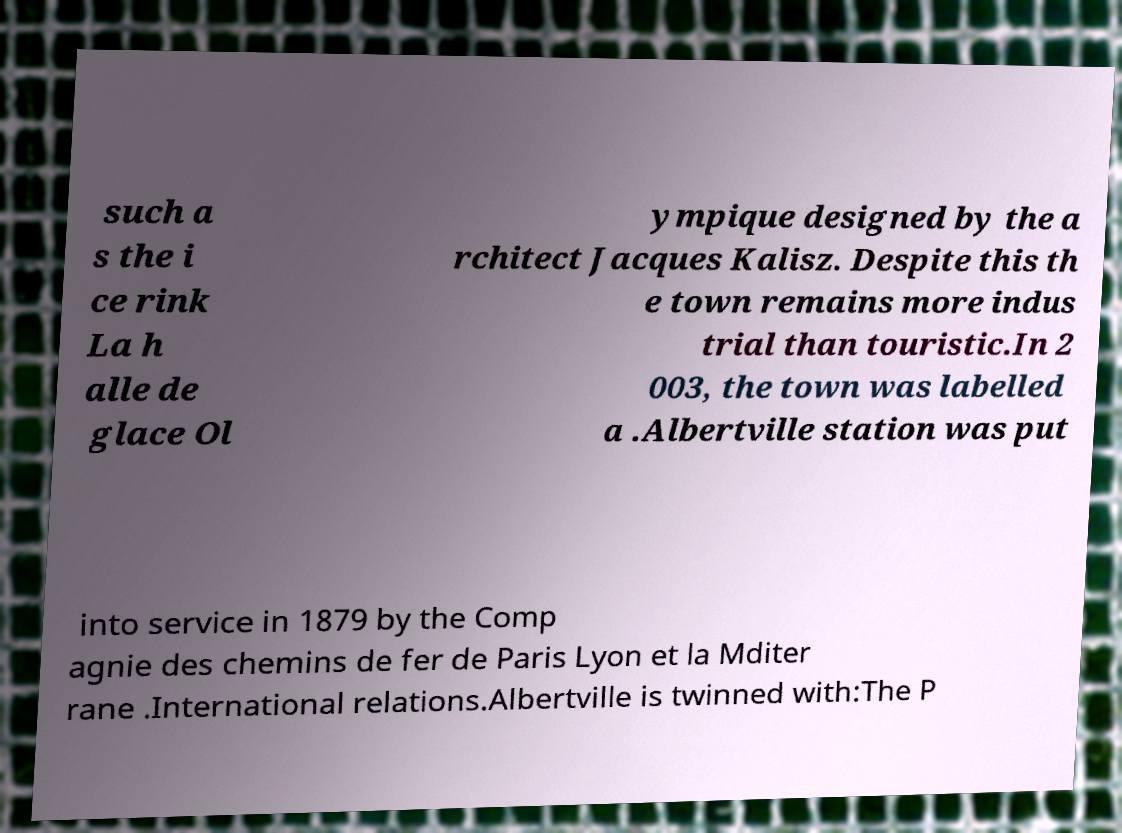Could you extract and type out the text from this image? such a s the i ce rink La h alle de glace Ol ympique designed by the a rchitect Jacques Kalisz. Despite this th e town remains more indus trial than touristic.In 2 003, the town was labelled a .Albertville station was put into service in 1879 by the Comp agnie des chemins de fer de Paris Lyon et la Mditer rane .International relations.Albertville is twinned with:The P 